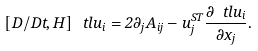<formula> <loc_0><loc_0><loc_500><loc_500>\left [ D / D t , H \right ] \ t l { u } _ { i } = 2 \partial _ { j } A _ { i j } - u _ { j } ^ { S T } \frac { \partial \ t l { u } _ { i } } { \partial x _ { j } } .</formula> 